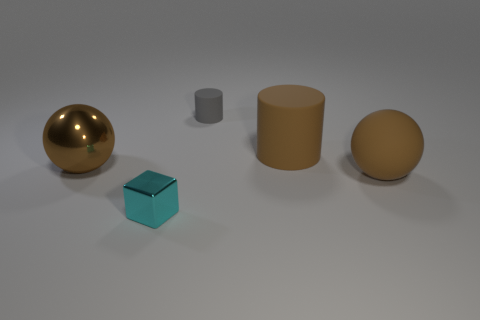Is the number of small cubes behind the large brown rubber cylinder the same as the number of cyan metal blocks behind the tiny gray rubber thing?
Your response must be concise. Yes. What shape is the big brown object that is behind the large brown sphere that is left of the cyan metal object?
Your answer should be very brief. Cylinder. There is another brown thing that is the same shape as the large shiny object; what is its material?
Your answer should be compact. Rubber. What is the color of the shiny ball that is the same size as the brown matte cylinder?
Your response must be concise. Brown. Are there an equal number of large cylinders that are left of the small cyan shiny cube and cyan metal blocks?
Offer a terse response. No. There is a shiny thing that is behind the ball right of the cyan object; what is its color?
Offer a terse response. Brown. There is a brown sphere to the left of the big ball to the right of the small shiny block; what size is it?
Give a very brief answer. Large. What size is the cylinder that is the same color as the metallic sphere?
Make the answer very short. Large. What number of other things are the same size as the brown metal sphere?
Your answer should be very brief. 2. What is the color of the large ball that is on the right side of the brown ball to the left of the cylinder that is left of the big cylinder?
Your response must be concise. Brown. 